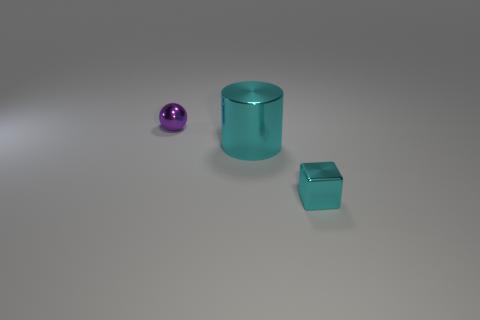Subtract all purple cubes. Subtract all yellow balls. How many cubes are left? 1 Add 1 cyan blocks. How many objects exist? 4 Subtract all spheres. How many objects are left? 2 Add 2 cyan metallic cylinders. How many cyan metallic cylinders are left? 3 Add 3 small cyan matte cubes. How many small cyan matte cubes exist? 3 Subtract 0 yellow spheres. How many objects are left? 3 Subtract all green rubber cubes. Subtract all tiny shiny things. How many objects are left? 1 